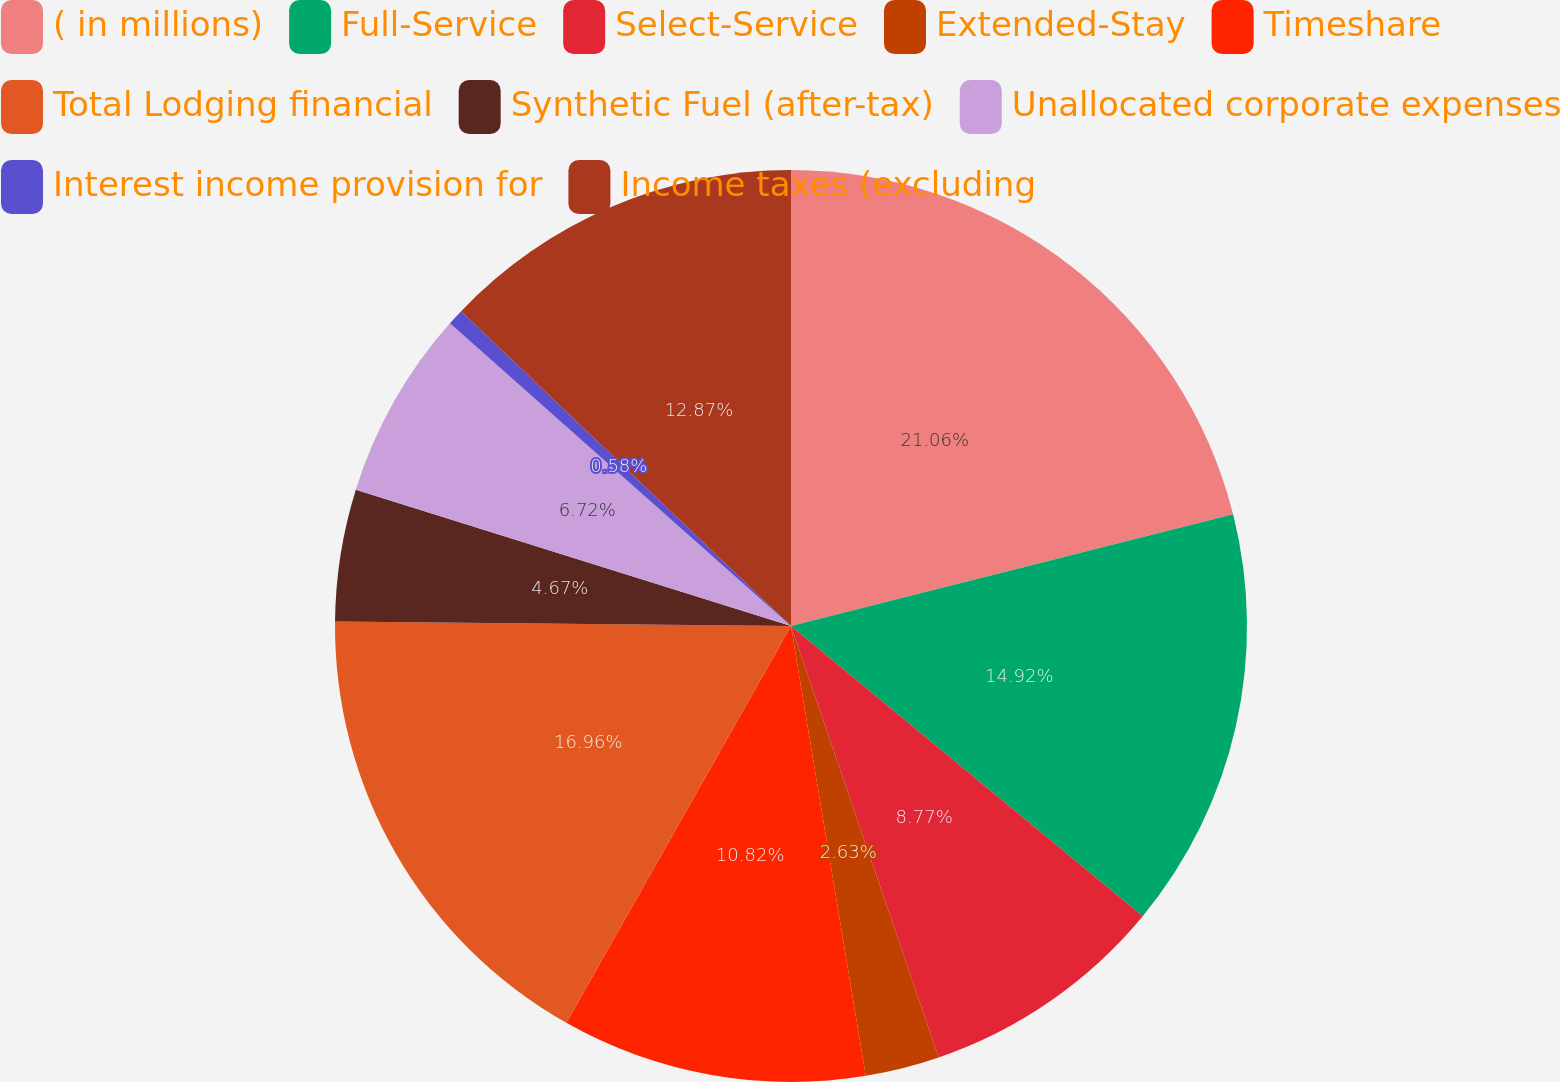Convert chart. <chart><loc_0><loc_0><loc_500><loc_500><pie_chart><fcel>( in millions)<fcel>Full-Service<fcel>Select-Service<fcel>Extended-Stay<fcel>Timeshare<fcel>Total Lodging financial<fcel>Synthetic Fuel (after-tax)<fcel>Unallocated corporate expenses<fcel>Interest income provision for<fcel>Income taxes (excluding<nl><fcel>21.06%<fcel>14.92%<fcel>8.77%<fcel>2.63%<fcel>10.82%<fcel>16.96%<fcel>4.67%<fcel>6.72%<fcel>0.58%<fcel>12.87%<nl></chart> 